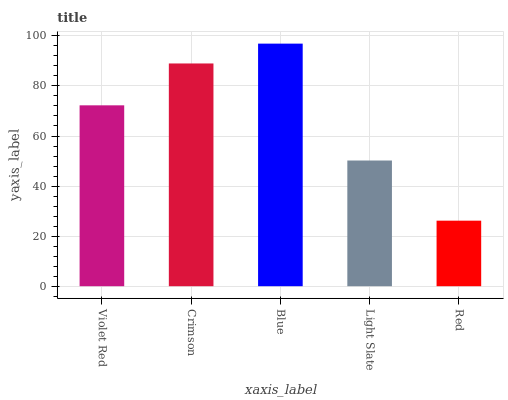Is Red the minimum?
Answer yes or no. Yes. Is Blue the maximum?
Answer yes or no. Yes. Is Crimson the minimum?
Answer yes or no. No. Is Crimson the maximum?
Answer yes or no. No. Is Crimson greater than Violet Red?
Answer yes or no. Yes. Is Violet Red less than Crimson?
Answer yes or no. Yes. Is Violet Red greater than Crimson?
Answer yes or no. No. Is Crimson less than Violet Red?
Answer yes or no. No. Is Violet Red the high median?
Answer yes or no. Yes. Is Violet Red the low median?
Answer yes or no. Yes. Is Red the high median?
Answer yes or no. No. Is Light Slate the low median?
Answer yes or no. No. 